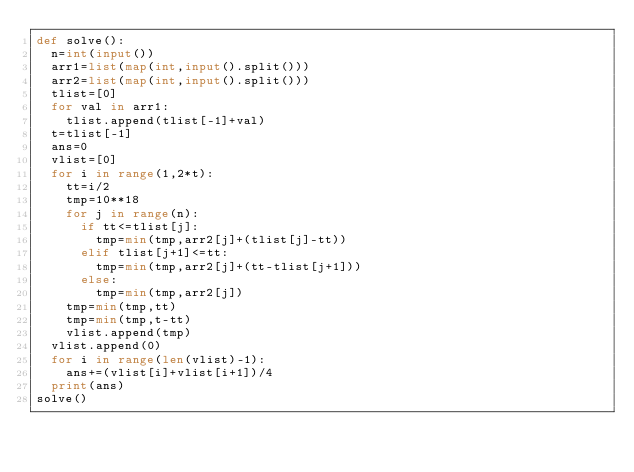<code> <loc_0><loc_0><loc_500><loc_500><_Python_>def solve():
  n=int(input())
  arr1=list(map(int,input().split()))
  arr2=list(map(int,input().split()))
  tlist=[0]
  for val in arr1:
    tlist.append(tlist[-1]+val)
  t=tlist[-1]
  ans=0
  vlist=[0]
  for i in range(1,2*t):
    tt=i/2
    tmp=10**18
    for j in range(n):
      if tt<=tlist[j]:
        tmp=min(tmp,arr2[j]+(tlist[j]-tt))
      elif tlist[j+1]<=tt:
        tmp=min(tmp,arr2[j]+(tt-tlist[j+1]))
      else:
        tmp=min(tmp,arr2[j])
    tmp=min(tmp,tt)
    tmp=min(tmp,t-tt)
    vlist.append(tmp)
  vlist.append(0)
  for i in range(len(vlist)-1):
    ans+=(vlist[i]+vlist[i+1])/4
  print(ans)
solve()</code> 